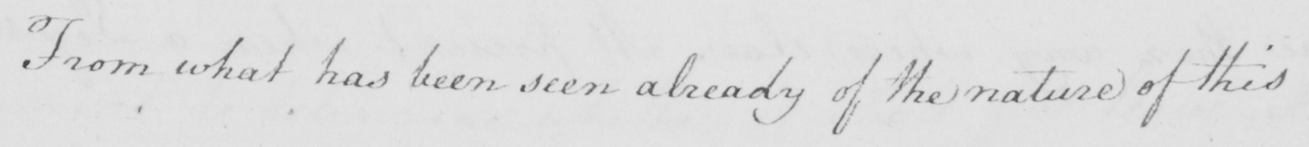What text is written in this handwritten line? From what has been seen already of the nature of this 